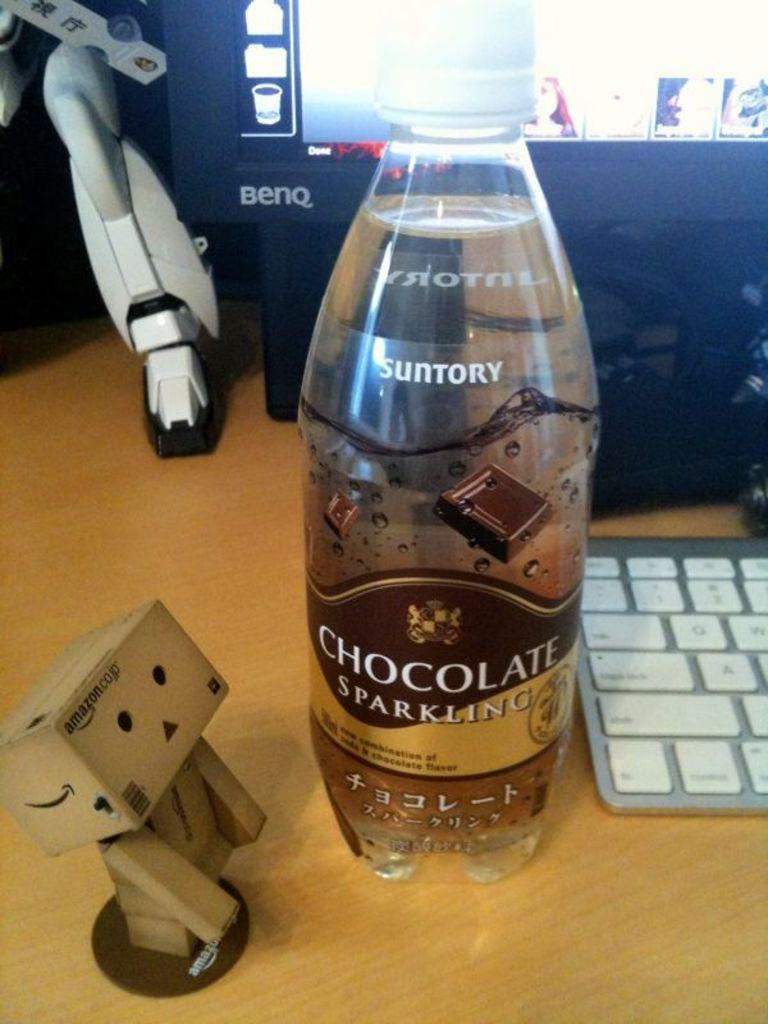<image>
Relay a brief, clear account of the picture shown. A bottle of chocolate sparkling water sits near a computer on a desk. 